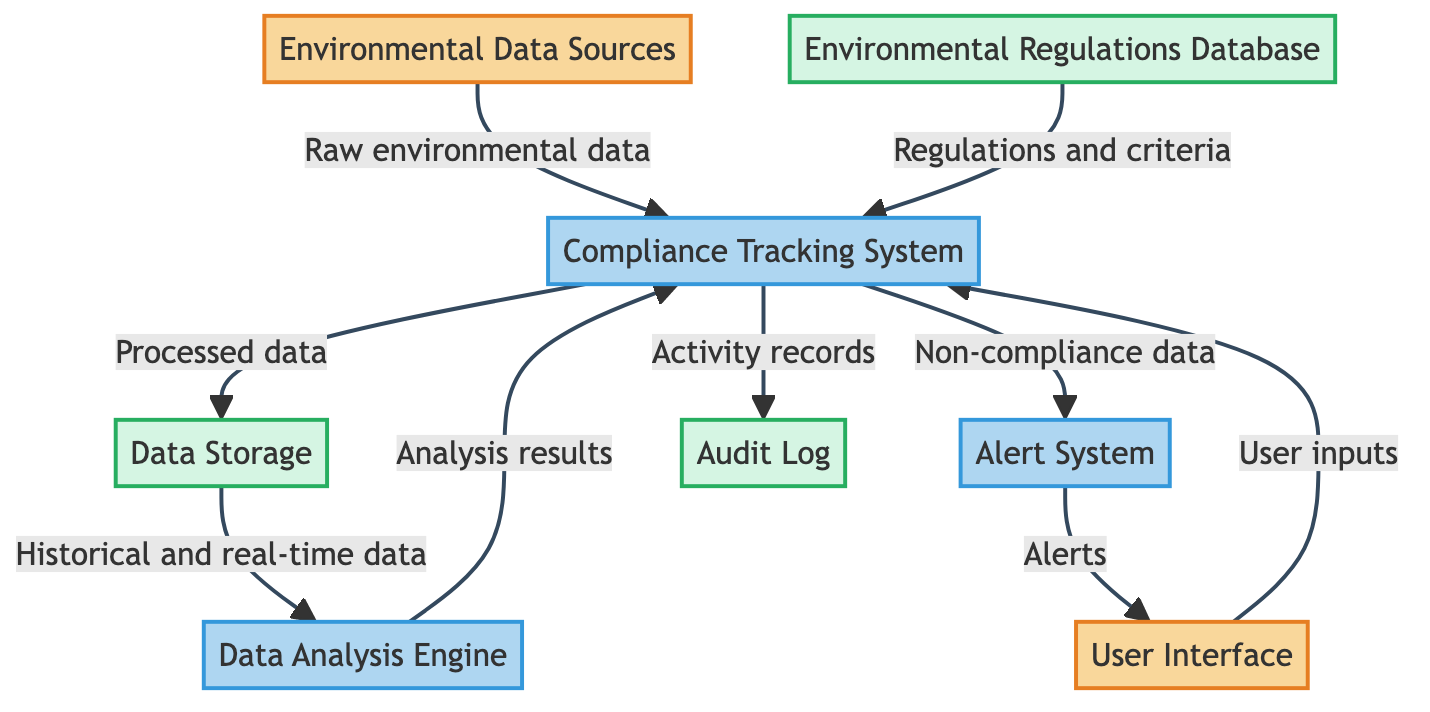What is the primary function of the Compliance Tracking System? The Compliance Tracking System is responsible for tracking compliance with environmental regulations. This is depicted as one of the processes in the diagram.
Answer: tracking compliance with environmental regulations How many external entities are represented in the diagram? In the diagram, there are two external entities: Environmental Data Sources and User Interface. By counting these nodes, we can determine the number of external entities present.
Answer: 2 Which component provides historical and real-time data to the Data Analysis Engine? The Data Storage provides both historical and real-time environmental data to the Data Analysis Engine, as the flow from Data Storage to Data Analysis Engine indicates this relationship.
Answer: Data Storage What type of data does the Alert System output? The Alert System outputs alerts, which are notifications generated in response to non-compliance or anomalies detected during data analysis. This is explicitly stated in the data flow from the Alert System to the User Interface.
Answer: alerts What data flows from the Compliance Tracking System to the Audit Log? The Compliance Tracking System sends activity records to the Audit Log for auditing purposes, as indicated by the data flow from the Compliance Tracking System to the Audit Log.
Answer: activity records What initiates the process of generating alerts? The process of generating alerts is initiated by non-compliance or anomaly data that is detected in the Compliance Tracking System, shown by the data flow from Compliance Tracking System to Alert System.
Answer: non-compliance or anomaly data Which entity interacts with the Compliance Tracking System to input user data? The User Interface interacts with the Compliance Tracking System by sending user inputs and interactions, as indicated by the directed data flow from User Interface to Compliance Tracking System.
Answer: User Interface Where is the processed environmental data ultimately stored? The processed environmental data is ultimately stored in the Data Storage, as shown by the flow from Compliance Tracking System to Data Storage indicating the storage of processed data.
Answer: Data Storage 